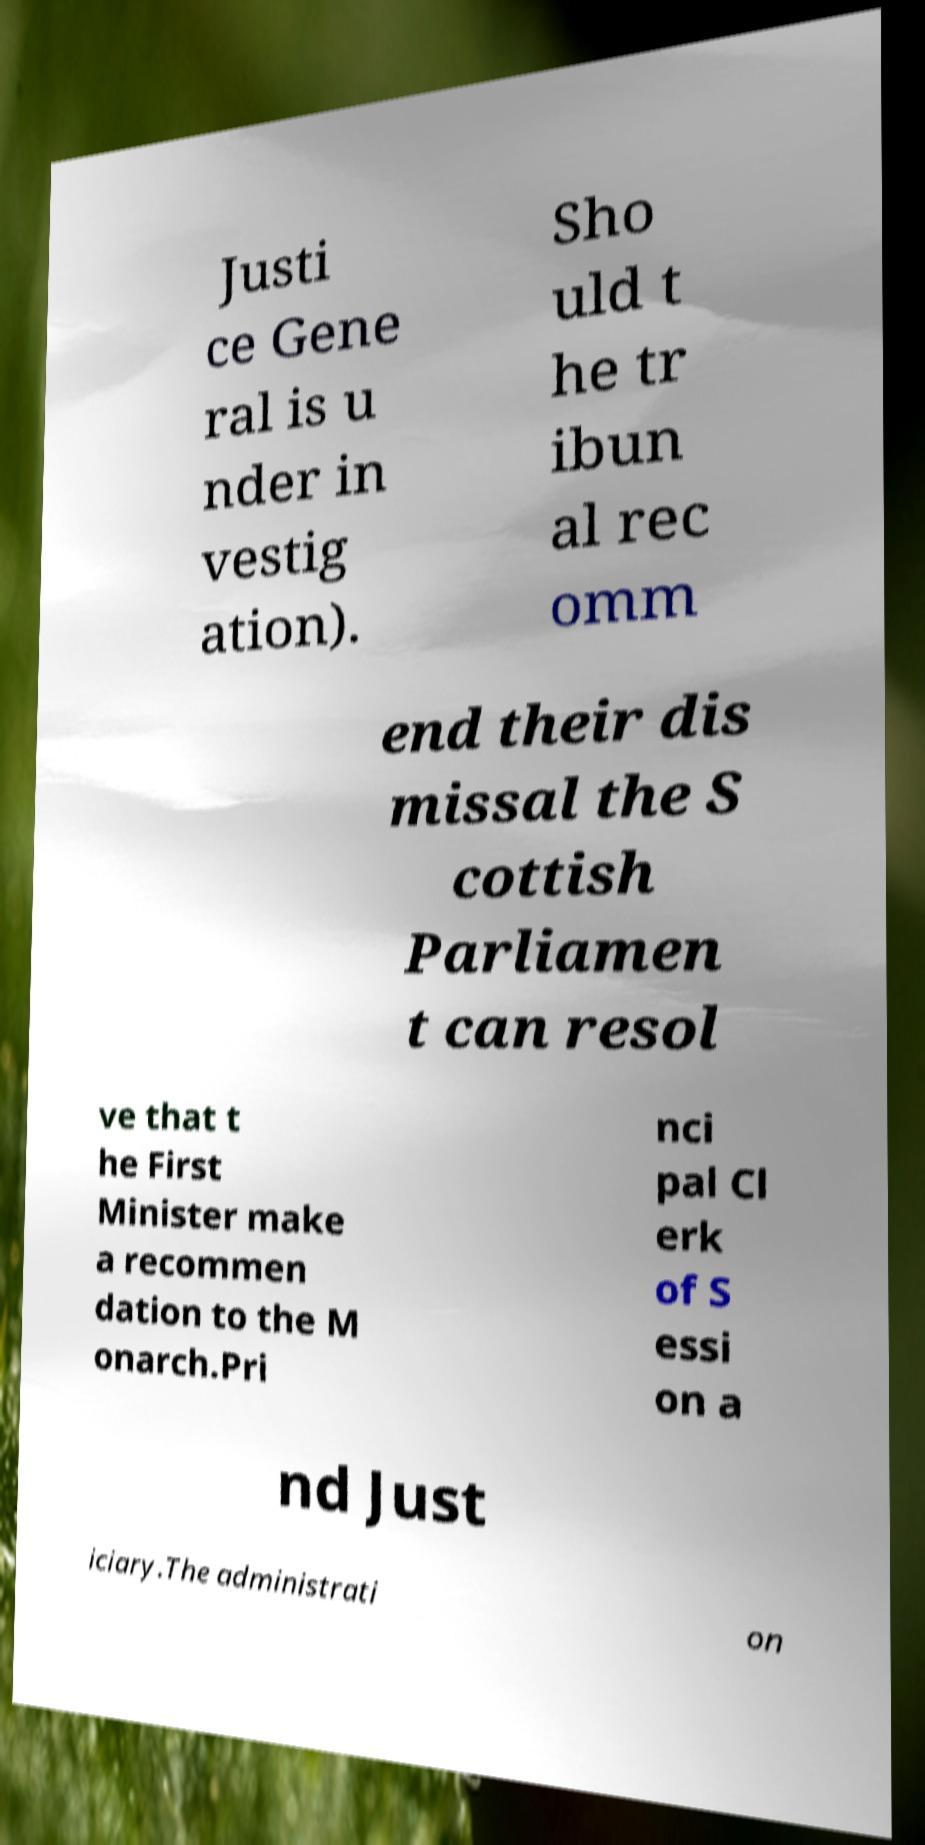Could you assist in decoding the text presented in this image and type it out clearly? Justi ce Gene ral is u nder in vestig ation). Sho uld t he tr ibun al rec omm end their dis missal the S cottish Parliamen t can resol ve that t he First Minister make a recommen dation to the M onarch.Pri nci pal Cl erk of S essi on a nd Just iciary.The administrati on 